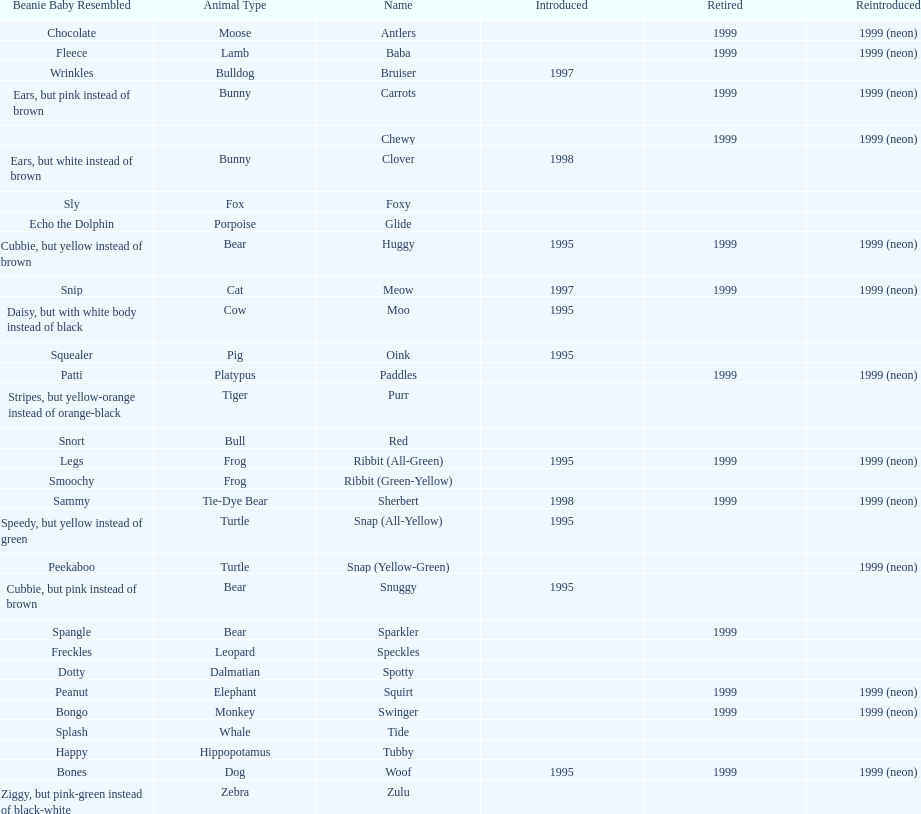What is the number of frog pillow pals? 2. 